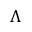<formula> <loc_0><loc_0><loc_500><loc_500>\Lambda</formula> 